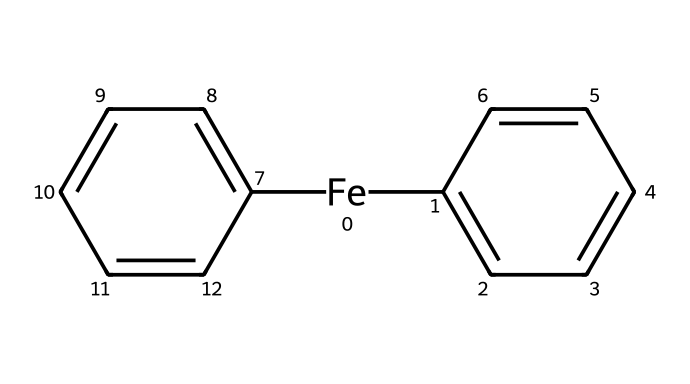How many carbon atoms are present in ferrocene? The SMILES representation indicates two cyclopentadiene rings, each containing 5 carbon atoms, and there are also five carbon atoms contributed by the iron bonding. Therefore, there are a total of 10 carbon atoms in the molecule.
Answer: 10 What is the coordination number of the iron atom in ferrocene? In ferrocene, the iron atom is bonded to two cyclopentadienyl rings in a sandwich structure, leading to a coordination number of 2.
Answer: 2 Identify the type of bonding present between the iron and the cyclopentadiene rings. The iron in ferrocene forms coordinate covalent bonds with the π-electrons from the cyclopentadiene rings, indicating a π backbonding interaction.
Answer: coordinate covalent What is the total number of hydrogen atoms in ferrocene? Each cyclopentadiene ring contributes 4 hydrogen atoms due to the loss of one hydrogen per ring during bonding with iron, leading to a total of 8 hydrogen atoms in ferrocene.
Answer: 8 What type of organometallic compound is ferrocene classified as? Ferrocene is classified as a metallocene, which contains a metal center sandwiched between two cyclopentadienyl anions.
Answer: metallocene What shape does the ferrocene molecule adopt? The molecule exhibits a sandwich conformation due to the arrangement of the cyclopentadiene rings above and below the iron center.
Answer: sandwich Describe the color typically associated with ferrocene. Ferrocene is typically known to exhibit an orange to reddish color due to its electronic structure and π-electron interactions.
Answer: orange to reddish 